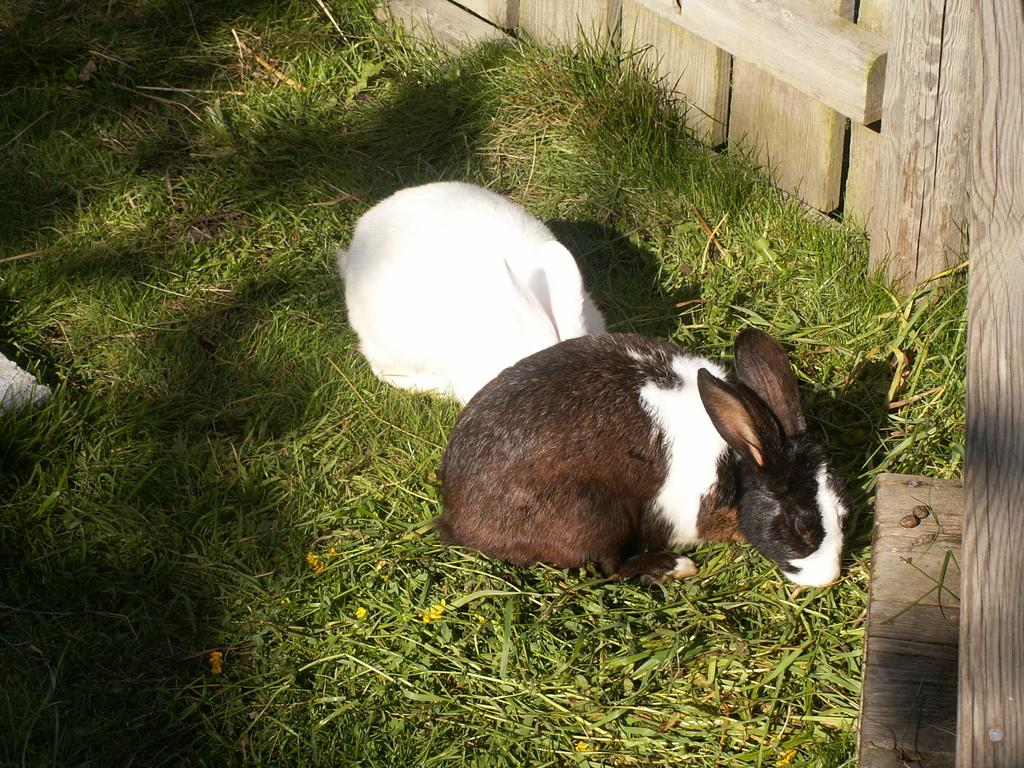How many rabbits are in the image? There are two rabbits in the image. Where are the rabbits located? The rabbits are on the surface of the grass. What type of structure can be seen in the image? There is a wooden fence in the image. What type of leather is being used to make the rabbits' clothing in the image? There is no leather or clothing present on the rabbits in the image; they are simply on the grass. 